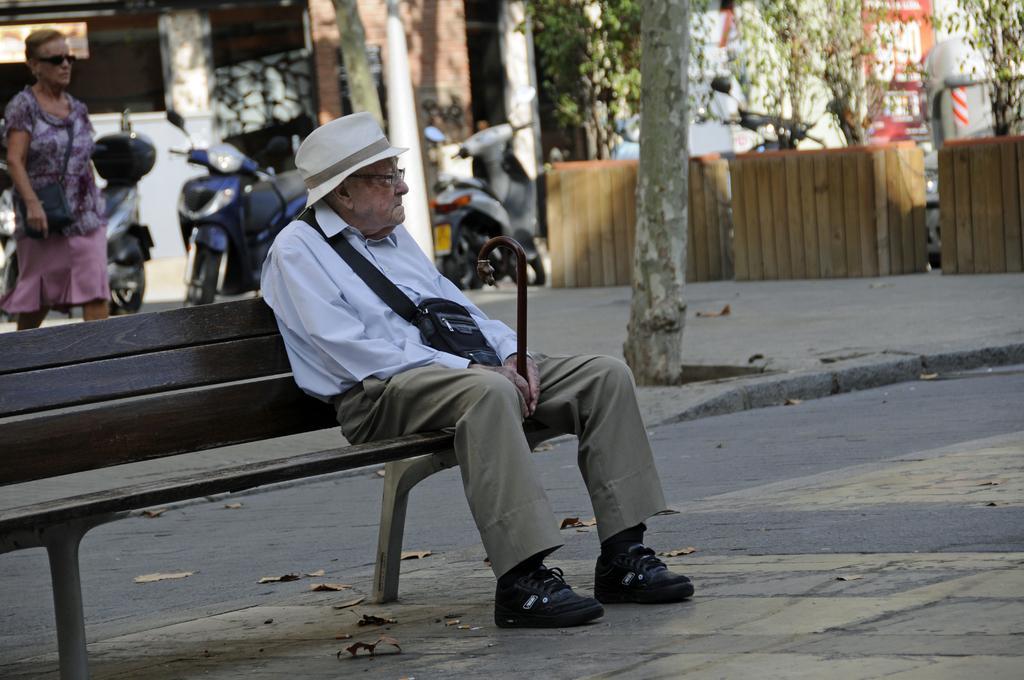Describe this image in one or two sentences. In this image I can see a person sitting on the bench. To the back of him there is a person walking. To the right there are trees,vehicles and the building. 